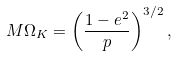Convert formula to latex. <formula><loc_0><loc_0><loc_500><loc_500>M \Omega _ { K } = \left ( \frac { 1 - e ^ { 2 } } { p } \right ) ^ { 3 / 2 } ,</formula> 